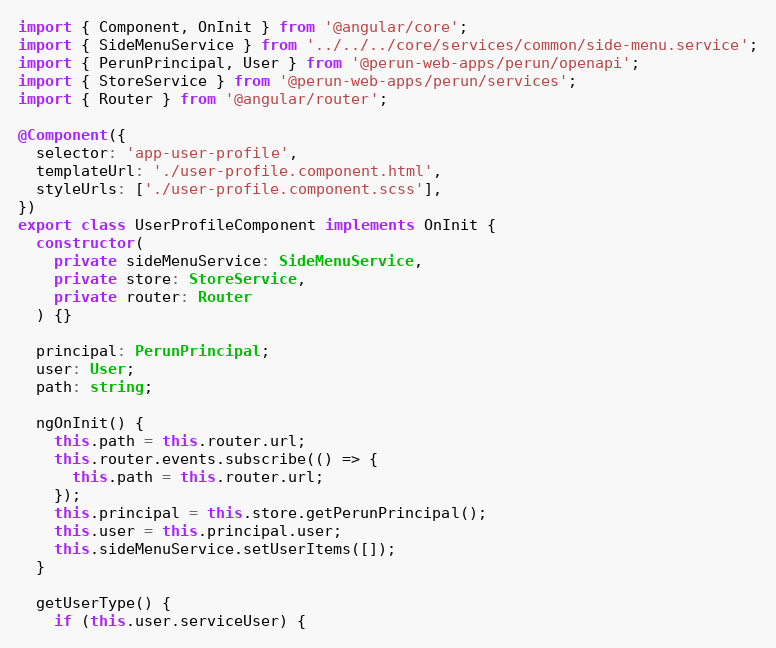Convert code to text. <code><loc_0><loc_0><loc_500><loc_500><_TypeScript_>import { Component, OnInit } from '@angular/core';
import { SideMenuService } from '../../../core/services/common/side-menu.service';
import { PerunPrincipal, User } from '@perun-web-apps/perun/openapi';
import { StoreService } from '@perun-web-apps/perun/services';
import { Router } from '@angular/router';

@Component({
  selector: 'app-user-profile',
  templateUrl: './user-profile.component.html',
  styleUrls: ['./user-profile.component.scss'],
})
export class UserProfileComponent implements OnInit {
  constructor(
    private sideMenuService: SideMenuService,
    private store: StoreService,
    private router: Router
  ) {}

  principal: PerunPrincipal;
  user: User;
  path: string;

  ngOnInit() {
    this.path = this.router.url;
    this.router.events.subscribe(() => {
      this.path = this.router.url;
    });
    this.principal = this.store.getPerunPrincipal();
    this.user = this.principal.user;
    this.sideMenuService.setUserItems([]);
  }

  getUserType() {
    if (this.user.serviceUser) {</code> 